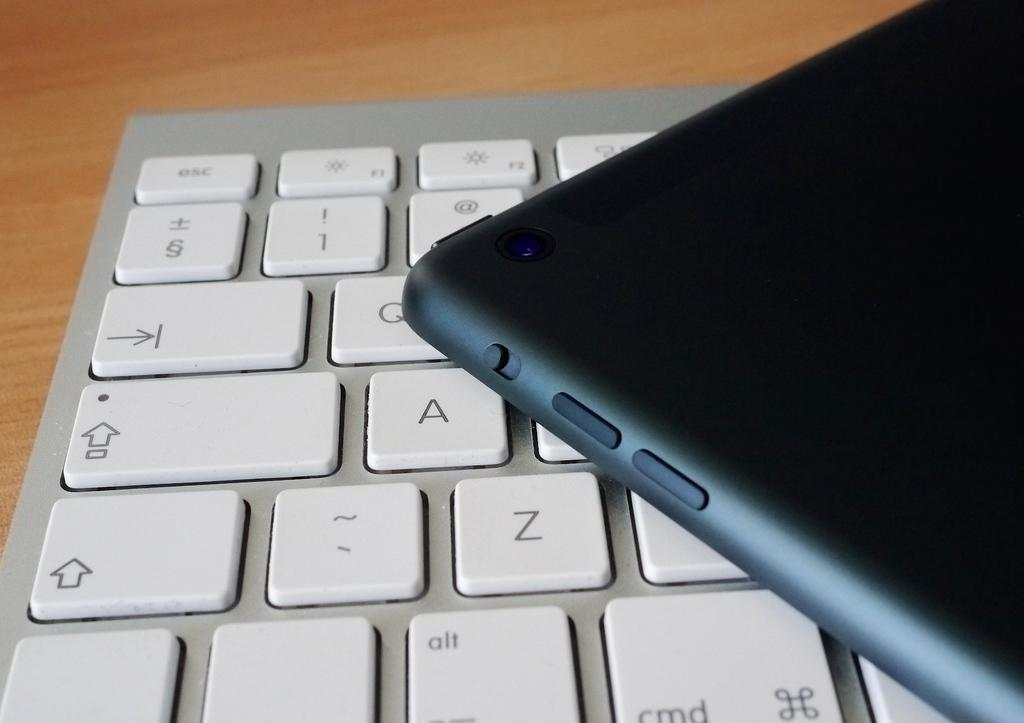<image>
Provide a brief description of the given image. A keyboard has the letters A and Z visible, amongst others. 